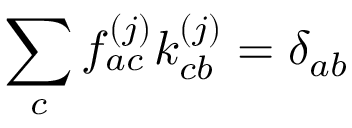Convert formula to latex. <formula><loc_0><loc_0><loc_500><loc_500>\sum _ { c } \mathcal { f } _ { a c } ^ { ( j ) } \mathcal { k } _ { c b } ^ { ( j ) } = \delta _ { a b }</formula> 